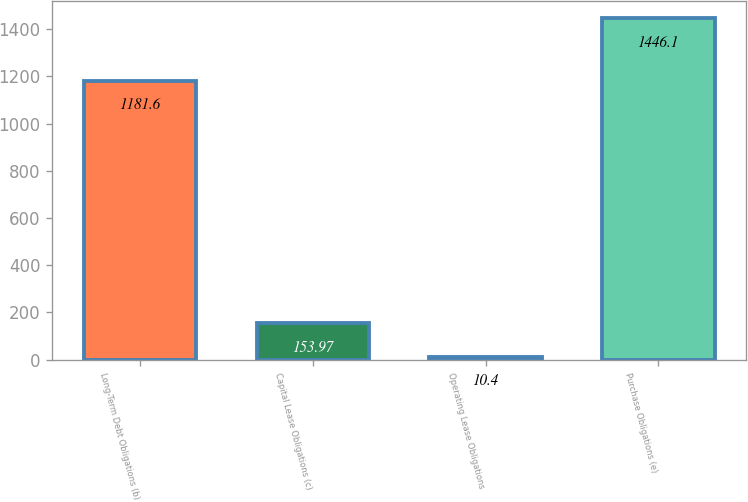<chart> <loc_0><loc_0><loc_500><loc_500><bar_chart><fcel>Long-Term Debt Obligations (b)<fcel>Capital Lease Obligations (c)<fcel>Operating Lease Obligations<fcel>Purchase Obligations (e)<nl><fcel>1181.6<fcel>153.97<fcel>10.4<fcel>1446.1<nl></chart> 